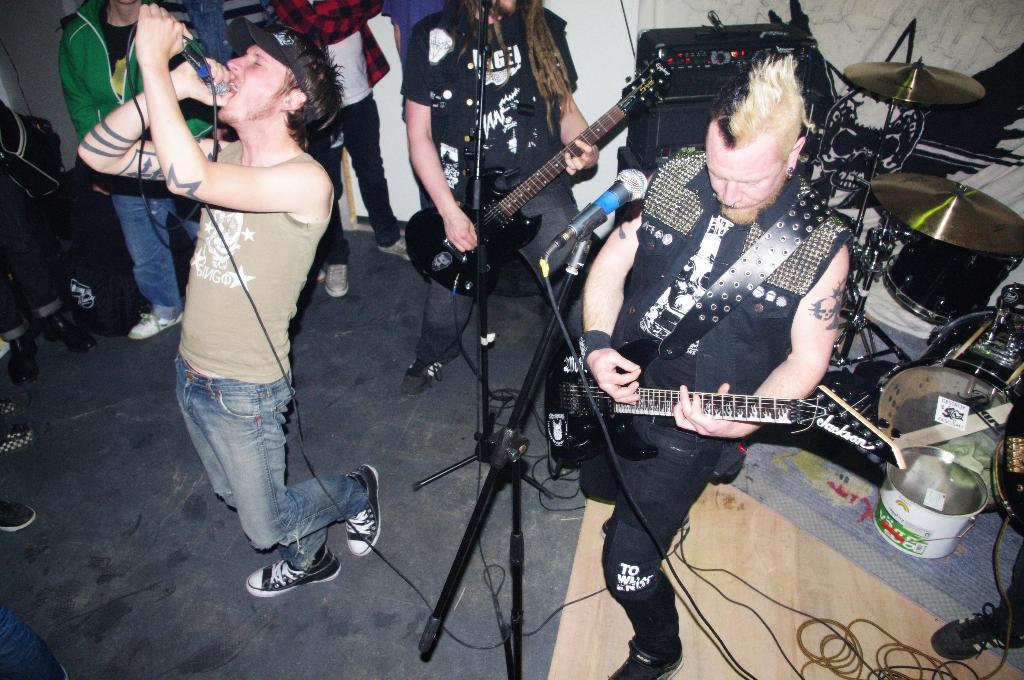Please provide a concise description of this image. In this image I can see group of people standing, the person in front is holding a microphone and singing. Background I can see few musical instruments. 